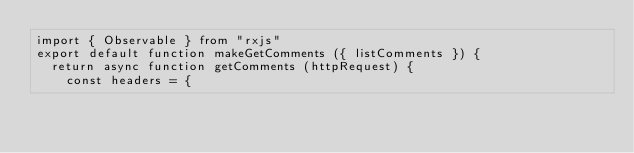<code> <loc_0><loc_0><loc_500><loc_500><_JavaScript_>import { Observable } from "rxjs"
export default function makeGetComments ({ listComments }) {
  return async function getComments (httpRequest) {
    const headers = {</code> 